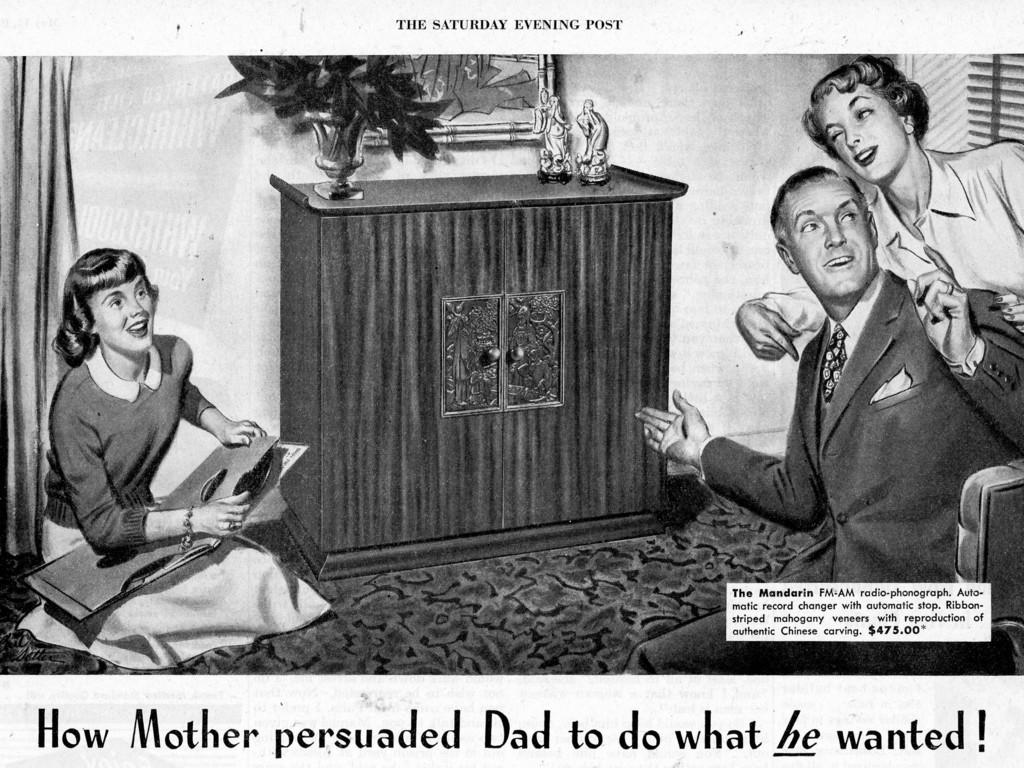What is the main object in the image? There is a paper in the image. What is depicted on the paper? There are three people depicted on the paper. What else can be seen in the image besides the paper? There is a flower pot and objects on a cupboard in the image. What is written on the paper? There is writing on the paper. Can you tell me how many alleys are visible in the image? There are no alleys present in the image. What advice does the mom give to the people depicted on the paper? There is no mom depicted in the image, and therefore no advice can be given. 